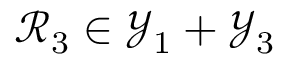Convert formula to latex. <formula><loc_0><loc_0><loc_500><loc_500>\mathcal { R } _ { 3 } \in \mathcal { Y } _ { 1 } + \mathcal { Y } _ { 3 }</formula> 